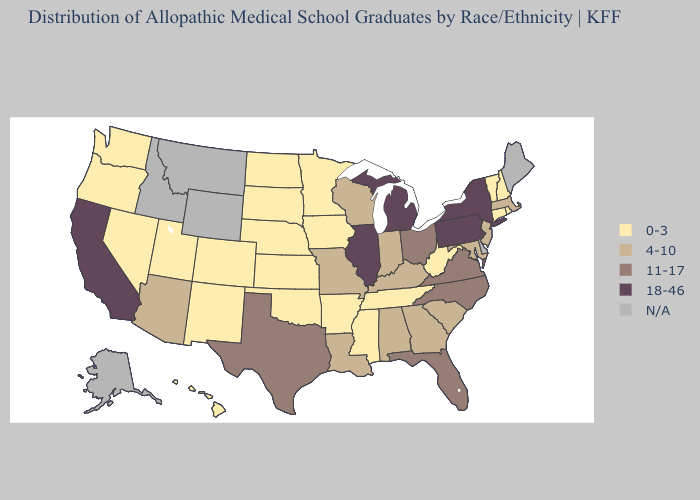Among the states that border Louisiana , which have the highest value?
Keep it brief. Texas. What is the highest value in states that border Tennessee?
Be succinct. 11-17. How many symbols are there in the legend?
Short answer required. 5. What is the highest value in the Northeast ?
Quick response, please. 18-46. What is the value of Alaska?
Be succinct. N/A. Name the states that have a value in the range 18-46?
Write a very short answer. California, Illinois, Michigan, New York, Pennsylvania. What is the value of South Dakota?
Write a very short answer. 0-3. What is the value of Oregon?
Write a very short answer. 0-3. What is the value of New Mexico?
Write a very short answer. 0-3. Name the states that have a value in the range 18-46?
Write a very short answer. California, Illinois, Michigan, New York, Pennsylvania. What is the value of Connecticut?
Short answer required. 0-3. Does New Hampshire have the lowest value in the USA?
Be succinct. Yes. What is the value of Nevada?
Give a very brief answer. 0-3. Name the states that have a value in the range N/A?
Keep it brief. Alaska, Delaware, Idaho, Maine, Montana, Wyoming. 